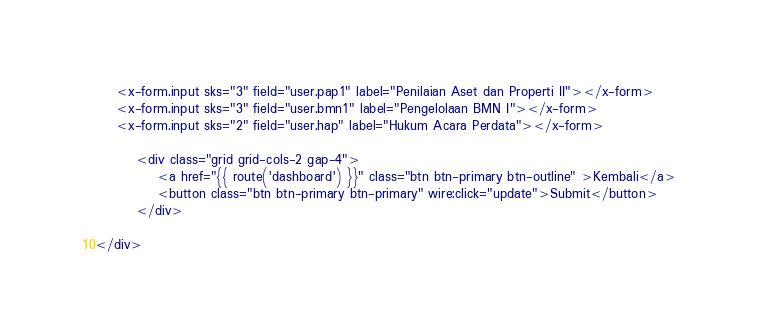Convert code to text. <code><loc_0><loc_0><loc_500><loc_500><_PHP_>    <x-form.input sks="3" field="user.pap1" label="Penilaian Aset dan Properti II"></x-form>
    <x-form.input sks="3" field="user.bmn1" label="Pengelolaan BMN I"></x-form>
    <x-form.input sks="2" field="user.hap" label="Hukum Acara Perdata"></x-form>

        <div class="grid grid-cols-2 gap-4">
            <a href="{{ route('dashboard') }}" class="btn btn-primary btn-outline" >Kembali</a>
            <button class="btn btn-primary btn-primary" wire:click="update">Submit</button>
        </div>

</div>

</code> 